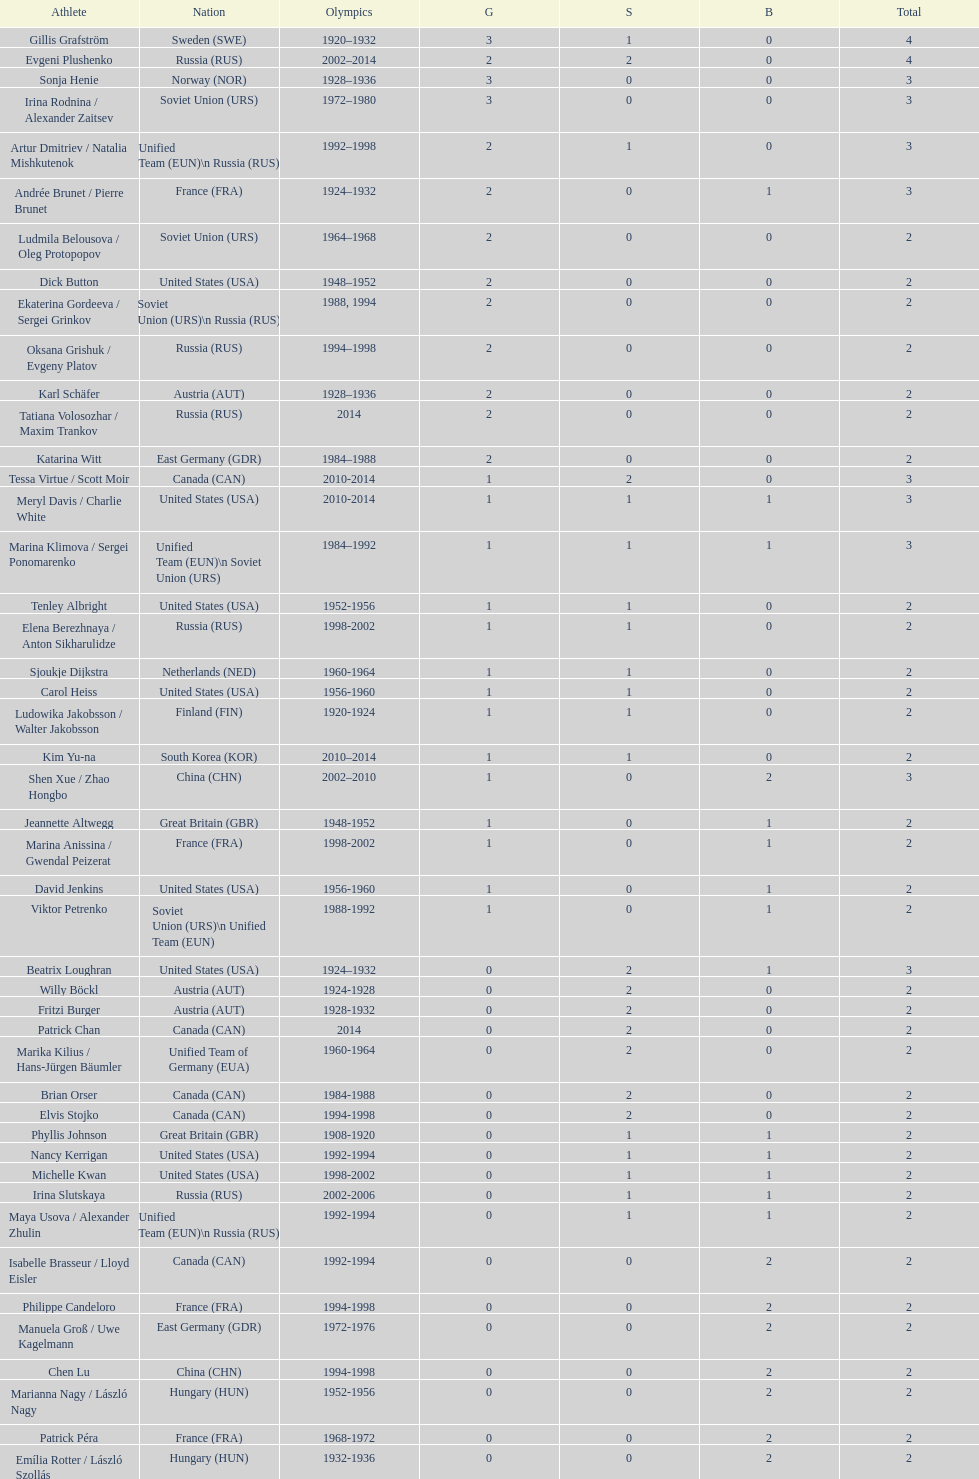How many total medals has the united states won in women's figure skating? 16. 